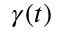Convert formula to latex. <formula><loc_0><loc_0><loc_500><loc_500>\gamma ( t )</formula> 